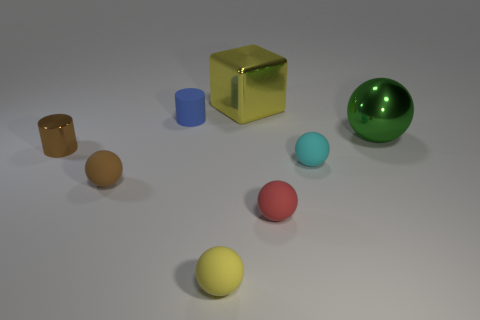Add 1 big cyan rubber cubes. How many objects exist? 9 Subtract all large balls. How many balls are left? 4 Subtract all brown cylinders. How many cylinders are left? 1 Subtract all green cylinders. Subtract all yellow blocks. How many cylinders are left? 2 Subtract 0 cyan cylinders. How many objects are left? 8 Subtract all cubes. How many objects are left? 7 Subtract 1 cylinders. How many cylinders are left? 1 Subtract all large brown matte cylinders. Subtract all brown shiny objects. How many objects are left? 7 Add 1 small matte cylinders. How many small matte cylinders are left? 2 Add 2 brown matte cylinders. How many brown matte cylinders exist? 2 